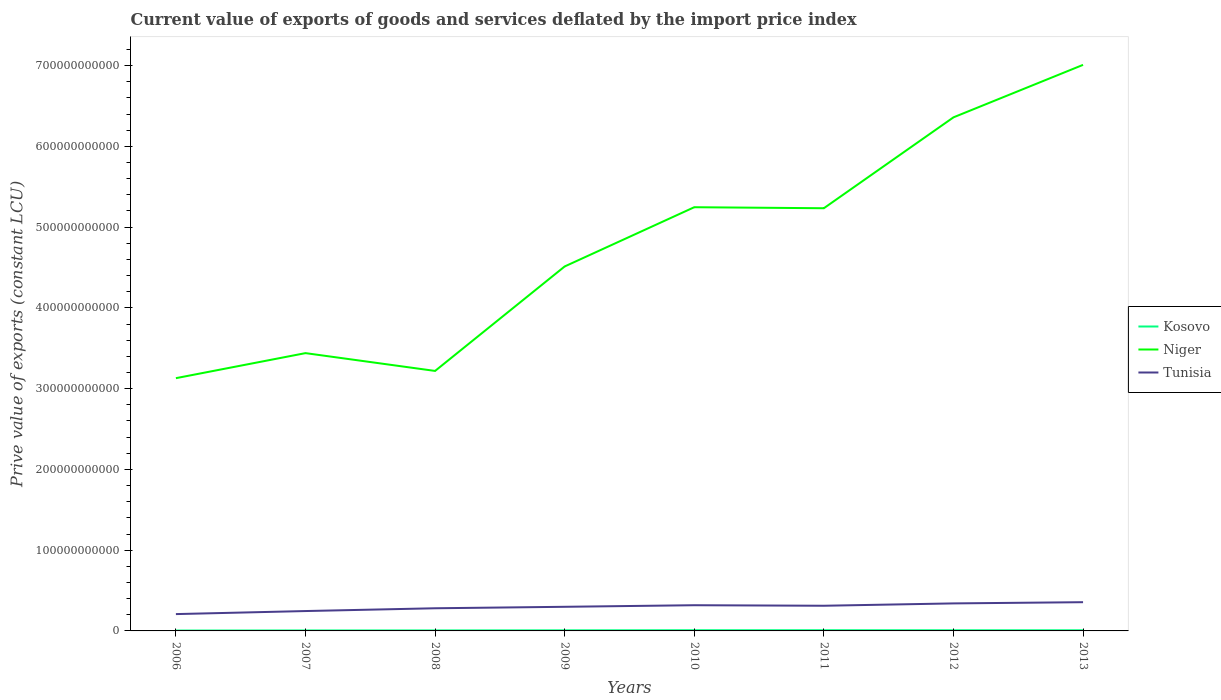Across all years, what is the maximum prive value of exports in Niger?
Provide a short and direct response. 3.13e+11. In which year was the prive value of exports in Kosovo maximum?
Offer a terse response. 2006. What is the total prive value of exports in Tunisia in the graph?
Give a very brief answer. -3.45e+09. What is the difference between the highest and the second highest prive value of exports in Niger?
Offer a terse response. 3.88e+11. What is the difference between the highest and the lowest prive value of exports in Niger?
Ensure brevity in your answer.  4. Is the prive value of exports in Tunisia strictly greater than the prive value of exports in Kosovo over the years?
Make the answer very short. No. What is the difference between two consecutive major ticks on the Y-axis?
Your response must be concise. 1.00e+11. Does the graph contain any zero values?
Offer a terse response. No. Does the graph contain grids?
Offer a very short reply. No. Where does the legend appear in the graph?
Your answer should be compact. Center right. How are the legend labels stacked?
Offer a very short reply. Vertical. What is the title of the graph?
Offer a very short reply. Current value of exports of goods and services deflated by the import price index. What is the label or title of the X-axis?
Make the answer very short. Years. What is the label or title of the Y-axis?
Provide a short and direct response. Prive value of exports (constant LCU). What is the Prive value of exports (constant LCU) of Kosovo in 2006?
Ensure brevity in your answer.  4.62e+08. What is the Prive value of exports (constant LCU) in Niger in 2006?
Make the answer very short. 3.13e+11. What is the Prive value of exports (constant LCU) in Tunisia in 2006?
Offer a terse response. 2.08e+1. What is the Prive value of exports (constant LCU) in Kosovo in 2007?
Offer a terse response. 5.88e+08. What is the Prive value of exports (constant LCU) in Niger in 2007?
Ensure brevity in your answer.  3.44e+11. What is the Prive value of exports (constant LCU) of Tunisia in 2007?
Give a very brief answer. 2.46e+1. What is the Prive value of exports (constant LCU) of Kosovo in 2008?
Make the answer very short. 6.11e+08. What is the Prive value of exports (constant LCU) of Niger in 2008?
Provide a succinct answer. 3.22e+11. What is the Prive value of exports (constant LCU) of Tunisia in 2008?
Provide a short and direct response. 2.81e+1. What is the Prive value of exports (constant LCU) of Kosovo in 2009?
Ensure brevity in your answer.  7.33e+08. What is the Prive value of exports (constant LCU) of Niger in 2009?
Your response must be concise. 4.51e+11. What is the Prive value of exports (constant LCU) of Tunisia in 2009?
Keep it short and to the point. 2.99e+1. What is the Prive value of exports (constant LCU) of Kosovo in 2010?
Offer a very short reply. 8.72e+08. What is the Prive value of exports (constant LCU) in Niger in 2010?
Give a very brief answer. 5.25e+11. What is the Prive value of exports (constant LCU) of Tunisia in 2010?
Your response must be concise. 3.18e+1. What is the Prive value of exports (constant LCU) in Kosovo in 2011?
Make the answer very short. 8.70e+08. What is the Prive value of exports (constant LCU) in Niger in 2011?
Make the answer very short. 5.23e+11. What is the Prive value of exports (constant LCU) in Tunisia in 2011?
Keep it short and to the point. 3.12e+1. What is the Prive value of exports (constant LCU) in Kosovo in 2012?
Your answer should be very brief. 8.13e+08. What is the Prive value of exports (constant LCU) of Niger in 2012?
Ensure brevity in your answer.  6.36e+11. What is the Prive value of exports (constant LCU) in Tunisia in 2012?
Your response must be concise. 3.41e+1. What is the Prive value of exports (constant LCU) in Kosovo in 2013?
Offer a terse response. 8.15e+08. What is the Prive value of exports (constant LCU) of Niger in 2013?
Make the answer very short. 7.01e+11. What is the Prive value of exports (constant LCU) of Tunisia in 2013?
Provide a short and direct response. 3.56e+1. Across all years, what is the maximum Prive value of exports (constant LCU) in Kosovo?
Your answer should be very brief. 8.72e+08. Across all years, what is the maximum Prive value of exports (constant LCU) in Niger?
Keep it short and to the point. 7.01e+11. Across all years, what is the maximum Prive value of exports (constant LCU) of Tunisia?
Your answer should be very brief. 3.56e+1. Across all years, what is the minimum Prive value of exports (constant LCU) in Kosovo?
Provide a short and direct response. 4.62e+08. Across all years, what is the minimum Prive value of exports (constant LCU) of Niger?
Offer a very short reply. 3.13e+11. Across all years, what is the minimum Prive value of exports (constant LCU) of Tunisia?
Offer a very short reply. 2.08e+1. What is the total Prive value of exports (constant LCU) of Kosovo in the graph?
Ensure brevity in your answer.  5.76e+09. What is the total Prive value of exports (constant LCU) in Niger in the graph?
Keep it short and to the point. 3.82e+12. What is the total Prive value of exports (constant LCU) of Tunisia in the graph?
Provide a short and direct response. 2.36e+11. What is the difference between the Prive value of exports (constant LCU) of Kosovo in 2006 and that in 2007?
Keep it short and to the point. -1.26e+08. What is the difference between the Prive value of exports (constant LCU) in Niger in 2006 and that in 2007?
Provide a succinct answer. -3.10e+1. What is the difference between the Prive value of exports (constant LCU) of Tunisia in 2006 and that in 2007?
Your answer should be very brief. -3.77e+09. What is the difference between the Prive value of exports (constant LCU) in Kosovo in 2006 and that in 2008?
Provide a short and direct response. -1.49e+08. What is the difference between the Prive value of exports (constant LCU) in Niger in 2006 and that in 2008?
Your answer should be compact. -8.97e+09. What is the difference between the Prive value of exports (constant LCU) in Tunisia in 2006 and that in 2008?
Your answer should be very brief. -7.22e+09. What is the difference between the Prive value of exports (constant LCU) in Kosovo in 2006 and that in 2009?
Make the answer very short. -2.71e+08. What is the difference between the Prive value of exports (constant LCU) of Niger in 2006 and that in 2009?
Make the answer very short. -1.38e+11. What is the difference between the Prive value of exports (constant LCU) in Tunisia in 2006 and that in 2009?
Keep it short and to the point. -9.04e+09. What is the difference between the Prive value of exports (constant LCU) of Kosovo in 2006 and that in 2010?
Provide a short and direct response. -4.10e+08. What is the difference between the Prive value of exports (constant LCU) of Niger in 2006 and that in 2010?
Give a very brief answer. -2.12e+11. What is the difference between the Prive value of exports (constant LCU) in Tunisia in 2006 and that in 2010?
Make the answer very short. -1.10e+1. What is the difference between the Prive value of exports (constant LCU) of Kosovo in 2006 and that in 2011?
Offer a terse response. -4.08e+08. What is the difference between the Prive value of exports (constant LCU) in Niger in 2006 and that in 2011?
Provide a succinct answer. -2.10e+11. What is the difference between the Prive value of exports (constant LCU) of Tunisia in 2006 and that in 2011?
Ensure brevity in your answer.  -1.03e+1. What is the difference between the Prive value of exports (constant LCU) of Kosovo in 2006 and that in 2012?
Ensure brevity in your answer.  -3.51e+08. What is the difference between the Prive value of exports (constant LCU) in Niger in 2006 and that in 2012?
Provide a succinct answer. -3.23e+11. What is the difference between the Prive value of exports (constant LCU) of Tunisia in 2006 and that in 2012?
Your answer should be compact. -1.32e+1. What is the difference between the Prive value of exports (constant LCU) of Kosovo in 2006 and that in 2013?
Make the answer very short. -3.53e+08. What is the difference between the Prive value of exports (constant LCU) of Niger in 2006 and that in 2013?
Provide a short and direct response. -3.88e+11. What is the difference between the Prive value of exports (constant LCU) in Tunisia in 2006 and that in 2013?
Make the answer very short. -1.48e+1. What is the difference between the Prive value of exports (constant LCU) of Kosovo in 2007 and that in 2008?
Make the answer very short. -2.31e+07. What is the difference between the Prive value of exports (constant LCU) in Niger in 2007 and that in 2008?
Offer a terse response. 2.20e+1. What is the difference between the Prive value of exports (constant LCU) in Tunisia in 2007 and that in 2008?
Keep it short and to the point. -3.45e+09. What is the difference between the Prive value of exports (constant LCU) of Kosovo in 2007 and that in 2009?
Your answer should be compact. -1.45e+08. What is the difference between the Prive value of exports (constant LCU) in Niger in 2007 and that in 2009?
Your answer should be very brief. -1.07e+11. What is the difference between the Prive value of exports (constant LCU) of Tunisia in 2007 and that in 2009?
Ensure brevity in your answer.  -5.27e+09. What is the difference between the Prive value of exports (constant LCU) in Kosovo in 2007 and that in 2010?
Give a very brief answer. -2.84e+08. What is the difference between the Prive value of exports (constant LCU) in Niger in 2007 and that in 2010?
Offer a terse response. -1.81e+11. What is the difference between the Prive value of exports (constant LCU) in Tunisia in 2007 and that in 2010?
Make the answer very short. -7.23e+09. What is the difference between the Prive value of exports (constant LCU) in Kosovo in 2007 and that in 2011?
Your answer should be very brief. -2.82e+08. What is the difference between the Prive value of exports (constant LCU) of Niger in 2007 and that in 2011?
Your answer should be compact. -1.79e+11. What is the difference between the Prive value of exports (constant LCU) of Tunisia in 2007 and that in 2011?
Ensure brevity in your answer.  -6.57e+09. What is the difference between the Prive value of exports (constant LCU) of Kosovo in 2007 and that in 2012?
Offer a terse response. -2.25e+08. What is the difference between the Prive value of exports (constant LCU) of Niger in 2007 and that in 2012?
Ensure brevity in your answer.  -2.92e+11. What is the difference between the Prive value of exports (constant LCU) of Tunisia in 2007 and that in 2012?
Give a very brief answer. -9.47e+09. What is the difference between the Prive value of exports (constant LCU) of Kosovo in 2007 and that in 2013?
Provide a short and direct response. -2.27e+08. What is the difference between the Prive value of exports (constant LCU) of Niger in 2007 and that in 2013?
Keep it short and to the point. -3.57e+11. What is the difference between the Prive value of exports (constant LCU) in Tunisia in 2007 and that in 2013?
Your answer should be compact. -1.10e+1. What is the difference between the Prive value of exports (constant LCU) of Kosovo in 2008 and that in 2009?
Make the answer very short. -1.22e+08. What is the difference between the Prive value of exports (constant LCU) in Niger in 2008 and that in 2009?
Offer a terse response. -1.29e+11. What is the difference between the Prive value of exports (constant LCU) in Tunisia in 2008 and that in 2009?
Keep it short and to the point. -1.82e+09. What is the difference between the Prive value of exports (constant LCU) of Kosovo in 2008 and that in 2010?
Ensure brevity in your answer.  -2.61e+08. What is the difference between the Prive value of exports (constant LCU) of Niger in 2008 and that in 2010?
Provide a succinct answer. -2.03e+11. What is the difference between the Prive value of exports (constant LCU) in Tunisia in 2008 and that in 2010?
Your answer should be compact. -3.78e+09. What is the difference between the Prive value of exports (constant LCU) in Kosovo in 2008 and that in 2011?
Make the answer very short. -2.59e+08. What is the difference between the Prive value of exports (constant LCU) in Niger in 2008 and that in 2011?
Offer a terse response. -2.01e+11. What is the difference between the Prive value of exports (constant LCU) in Tunisia in 2008 and that in 2011?
Your response must be concise. -3.12e+09. What is the difference between the Prive value of exports (constant LCU) of Kosovo in 2008 and that in 2012?
Your response must be concise. -2.02e+08. What is the difference between the Prive value of exports (constant LCU) of Niger in 2008 and that in 2012?
Provide a short and direct response. -3.14e+11. What is the difference between the Prive value of exports (constant LCU) of Tunisia in 2008 and that in 2012?
Your response must be concise. -6.02e+09. What is the difference between the Prive value of exports (constant LCU) in Kosovo in 2008 and that in 2013?
Provide a succinct answer. -2.04e+08. What is the difference between the Prive value of exports (constant LCU) of Niger in 2008 and that in 2013?
Make the answer very short. -3.79e+11. What is the difference between the Prive value of exports (constant LCU) in Tunisia in 2008 and that in 2013?
Offer a very short reply. -7.53e+09. What is the difference between the Prive value of exports (constant LCU) in Kosovo in 2009 and that in 2010?
Keep it short and to the point. -1.39e+08. What is the difference between the Prive value of exports (constant LCU) in Niger in 2009 and that in 2010?
Give a very brief answer. -7.34e+1. What is the difference between the Prive value of exports (constant LCU) in Tunisia in 2009 and that in 2010?
Provide a short and direct response. -1.96e+09. What is the difference between the Prive value of exports (constant LCU) of Kosovo in 2009 and that in 2011?
Make the answer very short. -1.38e+08. What is the difference between the Prive value of exports (constant LCU) of Niger in 2009 and that in 2011?
Offer a very short reply. -7.21e+1. What is the difference between the Prive value of exports (constant LCU) in Tunisia in 2009 and that in 2011?
Provide a short and direct response. -1.31e+09. What is the difference between the Prive value of exports (constant LCU) of Kosovo in 2009 and that in 2012?
Your answer should be very brief. -8.05e+07. What is the difference between the Prive value of exports (constant LCU) of Niger in 2009 and that in 2012?
Keep it short and to the point. -1.85e+11. What is the difference between the Prive value of exports (constant LCU) in Tunisia in 2009 and that in 2012?
Provide a short and direct response. -4.20e+09. What is the difference between the Prive value of exports (constant LCU) of Kosovo in 2009 and that in 2013?
Your answer should be compact. -8.19e+07. What is the difference between the Prive value of exports (constant LCU) of Niger in 2009 and that in 2013?
Offer a very short reply. -2.50e+11. What is the difference between the Prive value of exports (constant LCU) of Tunisia in 2009 and that in 2013?
Provide a short and direct response. -5.72e+09. What is the difference between the Prive value of exports (constant LCU) in Kosovo in 2010 and that in 2011?
Make the answer very short. 1.89e+06. What is the difference between the Prive value of exports (constant LCU) in Niger in 2010 and that in 2011?
Offer a very short reply. 1.26e+09. What is the difference between the Prive value of exports (constant LCU) of Tunisia in 2010 and that in 2011?
Your response must be concise. 6.51e+08. What is the difference between the Prive value of exports (constant LCU) in Kosovo in 2010 and that in 2012?
Provide a short and direct response. 5.89e+07. What is the difference between the Prive value of exports (constant LCU) of Niger in 2010 and that in 2012?
Your answer should be compact. -1.11e+11. What is the difference between the Prive value of exports (constant LCU) in Tunisia in 2010 and that in 2012?
Keep it short and to the point. -2.24e+09. What is the difference between the Prive value of exports (constant LCU) in Kosovo in 2010 and that in 2013?
Offer a very short reply. 5.75e+07. What is the difference between the Prive value of exports (constant LCU) of Niger in 2010 and that in 2013?
Keep it short and to the point. -1.76e+11. What is the difference between the Prive value of exports (constant LCU) in Tunisia in 2010 and that in 2013?
Ensure brevity in your answer.  -3.76e+09. What is the difference between the Prive value of exports (constant LCU) of Kosovo in 2011 and that in 2012?
Make the answer very short. 5.70e+07. What is the difference between the Prive value of exports (constant LCU) in Niger in 2011 and that in 2012?
Your answer should be compact. -1.13e+11. What is the difference between the Prive value of exports (constant LCU) of Tunisia in 2011 and that in 2012?
Your answer should be compact. -2.90e+09. What is the difference between the Prive value of exports (constant LCU) of Kosovo in 2011 and that in 2013?
Give a very brief answer. 5.57e+07. What is the difference between the Prive value of exports (constant LCU) of Niger in 2011 and that in 2013?
Give a very brief answer. -1.78e+11. What is the difference between the Prive value of exports (constant LCU) in Tunisia in 2011 and that in 2013?
Your answer should be very brief. -4.41e+09. What is the difference between the Prive value of exports (constant LCU) in Kosovo in 2012 and that in 2013?
Keep it short and to the point. -1.38e+06. What is the difference between the Prive value of exports (constant LCU) in Niger in 2012 and that in 2013?
Your answer should be compact. -6.50e+1. What is the difference between the Prive value of exports (constant LCU) in Tunisia in 2012 and that in 2013?
Keep it short and to the point. -1.51e+09. What is the difference between the Prive value of exports (constant LCU) of Kosovo in 2006 and the Prive value of exports (constant LCU) of Niger in 2007?
Your response must be concise. -3.44e+11. What is the difference between the Prive value of exports (constant LCU) of Kosovo in 2006 and the Prive value of exports (constant LCU) of Tunisia in 2007?
Offer a very short reply. -2.41e+1. What is the difference between the Prive value of exports (constant LCU) in Niger in 2006 and the Prive value of exports (constant LCU) in Tunisia in 2007?
Give a very brief answer. 2.88e+11. What is the difference between the Prive value of exports (constant LCU) in Kosovo in 2006 and the Prive value of exports (constant LCU) in Niger in 2008?
Provide a succinct answer. -3.21e+11. What is the difference between the Prive value of exports (constant LCU) in Kosovo in 2006 and the Prive value of exports (constant LCU) in Tunisia in 2008?
Provide a short and direct response. -2.76e+1. What is the difference between the Prive value of exports (constant LCU) in Niger in 2006 and the Prive value of exports (constant LCU) in Tunisia in 2008?
Provide a short and direct response. 2.85e+11. What is the difference between the Prive value of exports (constant LCU) in Kosovo in 2006 and the Prive value of exports (constant LCU) in Niger in 2009?
Offer a very short reply. -4.51e+11. What is the difference between the Prive value of exports (constant LCU) in Kosovo in 2006 and the Prive value of exports (constant LCU) in Tunisia in 2009?
Provide a short and direct response. -2.94e+1. What is the difference between the Prive value of exports (constant LCU) of Niger in 2006 and the Prive value of exports (constant LCU) of Tunisia in 2009?
Your response must be concise. 2.83e+11. What is the difference between the Prive value of exports (constant LCU) of Kosovo in 2006 and the Prive value of exports (constant LCU) of Niger in 2010?
Offer a very short reply. -5.24e+11. What is the difference between the Prive value of exports (constant LCU) in Kosovo in 2006 and the Prive value of exports (constant LCU) in Tunisia in 2010?
Keep it short and to the point. -3.14e+1. What is the difference between the Prive value of exports (constant LCU) of Niger in 2006 and the Prive value of exports (constant LCU) of Tunisia in 2010?
Keep it short and to the point. 2.81e+11. What is the difference between the Prive value of exports (constant LCU) in Kosovo in 2006 and the Prive value of exports (constant LCU) in Niger in 2011?
Make the answer very short. -5.23e+11. What is the difference between the Prive value of exports (constant LCU) of Kosovo in 2006 and the Prive value of exports (constant LCU) of Tunisia in 2011?
Give a very brief answer. -3.07e+1. What is the difference between the Prive value of exports (constant LCU) of Niger in 2006 and the Prive value of exports (constant LCU) of Tunisia in 2011?
Offer a very short reply. 2.82e+11. What is the difference between the Prive value of exports (constant LCU) of Kosovo in 2006 and the Prive value of exports (constant LCU) of Niger in 2012?
Keep it short and to the point. -6.35e+11. What is the difference between the Prive value of exports (constant LCU) in Kosovo in 2006 and the Prive value of exports (constant LCU) in Tunisia in 2012?
Your answer should be compact. -3.36e+1. What is the difference between the Prive value of exports (constant LCU) of Niger in 2006 and the Prive value of exports (constant LCU) of Tunisia in 2012?
Your answer should be compact. 2.79e+11. What is the difference between the Prive value of exports (constant LCU) of Kosovo in 2006 and the Prive value of exports (constant LCU) of Niger in 2013?
Your answer should be very brief. -7.00e+11. What is the difference between the Prive value of exports (constant LCU) in Kosovo in 2006 and the Prive value of exports (constant LCU) in Tunisia in 2013?
Keep it short and to the point. -3.51e+1. What is the difference between the Prive value of exports (constant LCU) of Niger in 2006 and the Prive value of exports (constant LCU) of Tunisia in 2013?
Your answer should be very brief. 2.77e+11. What is the difference between the Prive value of exports (constant LCU) of Kosovo in 2007 and the Prive value of exports (constant LCU) of Niger in 2008?
Provide a succinct answer. -3.21e+11. What is the difference between the Prive value of exports (constant LCU) in Kosovo in 2007 and the Prive value of exports (constant LCU) in Tunisia in 2008?
Provide a short and direct response. -2.75e+1. What is the difference between the Prive value of exports (constant LCU) of Niger in 2007 and the Prive value of exports (constant LCU) of Tunisia in 2008?
Ensure brevity in your answer.  3.16e+11. What is the difference between the Prive value of exports (constant LCU) of Kosovo in 2007 and the Prive value of exports (constant LCU) of Niger in 2009?
Your answer should be compact. -4.51e+11. What is the difference between the Prive value of exports (constant LCU) of Kosovo in 2007 and the Prive value of exports (constant LCU) of Tunisia in 2009?
Your response must be concise. -2.93e+1. What is the difference between the Prive value of exports (constant LCU) of Niger in 2007 and the Prive value of exports (constant LCU) of Tunisia in 2009?
Give a very brief answer. 3.14e+11. What is the difference between the Prive value of exports (constant LCU) of Kosovo in 2007 and the Prive value of exports (constant LCU) of Niger in 2010?
Your answer should be very brief. -5.24e+11. What is the difference between the Prive value of exports (constant LCU) of Kosovo in 2007 and the Prive value of exports (constant LCU) of Tunisia in 2010?
Keep it short and to the point. -3.12e+1. What is the difference between the Prive value of exports (constant LCU) in Niger in 2007 and the Prive value of exports (constant LCU) in Tunisia in 2010?
Ensure brevity in your answer.  3.12e+11. What is the difference between the Prive value of exports (constant LCU) of Kosovo in 2007 and the Prive value of exports (constant LCU) of Niger in 2011?
Your response must be concise. -5.23e+11. What is the difference between the Prive value of exports (constant LCU) of Kosovo in 2007 and the Prive value of exports (constant LCU) of Tunisia in 2011?
Provide a short and direct response. -3.06e+1. What is the difference between the Prive value of exports (constant LCU) in Niger in 2007 and the Prive value of exports (constant LCU) in Tunisia in 2011?
Your response must be concise. 3.13e+11. What is the difference between the Prive value of exports (constant LCU) in Kosovo in 2007 and the Prive value of exports (constant LCU) in Niger in 2012?
Make the answer very short. -6.35e+11. What is the difference between the Prive value of exports (constant LCU) in Kosovo in 2007 and the Prive value of exports (constant LCU) in Tunisia in 2012?
Your response must be concise. -3.35e+1. What is the difference between the Prive value of exports (constant LCU) in Niger in 2007 and the Prive value of exports (constant LCU) in Tunisia in 2012?
Provide a short and direct response. 3.10e+11. What is the difference between the Prive value of exports (constant LCU) of Kosovo in 2007 and the Prive value of exports (constant LCU) of Niger in 2013?
Ensure brevity in your answer.  -7.00e+11. What is the difference between the Prive value of exports (constant LCU) of Kosovo in 2007 and the Prive value of exports (constant LCU) of Tunisia in 2013?
Provide a succinct answer. -3.50e+1. What is the difference between the Prive value of exports (constant LCU) of Niger in 2007 and the Prive value of exports (constant LCU) of Tunisia in 2013?
Your answer should be very brief. 3.08e+11. What is the difference between the Prive value of exports (constant LCU) of Kosovo in 2008 and the Prive value of exports (constant LCU) of Niger in 2009?
Make the answer very short. -4.51e+11. What is the difference between the Prive value of exports (constant LCU) of Kosovo in 2008 and the Prive value of exports (constant LCU) of Tunisia in 2009?
Your answer should be compact. -2.93e+1. What is the difference between the Prive value of exports (constant LCU) in Niger in 2008 and the Prive value of exports (constant LCU) in Tunisia in 2009?
Offer a very short reply. 2.92e+11. What is the difference between the Prive value of exports (constant LCU) of Kosovo in 2008 and the Prive value of exports (constant LCU) of Niger in 2010?
Your response must be concise. -5.24e+11. What is the difference between the Prive value of exports (constant LCU) in Kosovo in 2008 and the Prive value of exports (constant LCU) in Tunisia in 2010?
Keep it short and to the point. -3.12e+1. What is the difference between the Prive value of exports (constant LCU) in Niger in 2008 and the Prive value of exports (constant LCU) in Tunisia in 2010?
Your answer should be very brief. 2.90e+11. What is the difference between the Prive value of exports (constant LCU) in Kosovo in 2008 and the Prive value of exports (constant LCU) in Niger in 2011?
Your answer should be compact. -5.23e+11. What is the difference between the Prive value of exports (constant LCU) of Kosovo in 2008 and the Prive value of exports (constant LCU) of Tunisia in 2011?
Provide a succinct answer. -3.06e+1. What is the difference between the Prive value of exports (constant LCU) in Niger in 2008 and the Prive value of exports (constant LCU) in Tunisia in 2011?
Provide a succinct answer. 2.91e+11. What is the difference between the Prive value of exports (constant LCU) in Kosovo in 2008 and the Prive value of exports (constant LCU) in Niger in 2012?
Make the answer very short. -6.35e+11. What is the difference between the Prive value of exports (constant LCU) in Kosovo in 2008 and the Prive value of exports (constant LCU) in Tunisia in 2012?
Ensure brevity in your answer.  -3.35e+1. What is the difference between the Prive value of exports (constant LCU) in Niger in 2008 and the Prive value of exports (constant LCU) in Tunisia in 2012?
Your answer should be very brief. 2.88e+11. What is the difference between the Prive value of exports (constant LCU) of Kosovo in 2008 and the Prive value of exports (constant LCU) of Niger in 2013?
Your answer should be compact. -7.00e+11. What is the difference between the Prive value of exports (constant LCU) in Kosovo in 2008 and the Prive value of exports (constant LCU) in Tunisia in 2013?
Keep it short and to the point. -3.50e+1. What is the difference between the Prive value of exports (constant LCU) in Niger in 2008 and the Prive value of exports (constant LCU) in Tunisia in 2013?
Offer a terse response. 2.86e+11. What is the difference between the Prive value of exports (constant LCU) of Kosovo in 2009 and the Prive value of exports (constant LCU) of Niger in 2010?
Offer a terse response. -5.24e+11. What is the difference between the Prive value of exports (constant LCU) of Kosovo in 2009 and the Prive value of exports (constant LCU) of Tunisia in 2010?
Ensure brevity in your answer.  -3.11e+1. What is the difference between the Prive value of exports (constant LCU) of Niger in 2009 and the Prive value of exports (constant LCU) of Tunisia in 2010?
Your response must be concise. 4.19e+11. What is the difference between the Prive value of exports (constant LCU) in Kosovo in 2009 and the Prive value of exports (constant LCU) in Niger in 2011?
Offer a terse response. -5.23e+11. What is the difference between the Prive value of exports (constant LCU) of Kosovo in 2009 and the Prive value of exports (constant LCU) of Tunisia in 2011?
Provide a short and direct response. -3.04e+1. What is the difference between the Prive value of exports (constant LCU) in Niger in 2009 and the Prive value of exports (constant LCU) in Tunisia in 2011?
Ensure brevity in your answer.  4.20e+11. What is the difference between the Prive value of exports (constant LCU) in Kosovo in 2009 and the Prive value of exports (constant LCU) in Niger in 2012?
Provide a short and direct response. -6.35e+11. What is the difference between the Prive value of exports (constant LCU) of Kosovo in 2009 and the Prive value of exports (constant LCU) of Tunisia in 2012?
Give a very brief answer. -3.33e+1. What is the difference between the Prive value of exports (constant LCU) of Niger in 2009 and the Prive value of exports (constant LCU) of Tunisia in 2012?
Provide a succinct answer. 4.17e+11. What is the difference between the Prive value of exports (constant LCU) of Kosovo in 2009 and the Prive value of exports (constant LCU) of Niger in 2013?
Offer a terse response. -7.00e+11. What is the difference between the Prive value of exports (constant LCU) of Kosovo in 2009 and the Prive value of exports (constant LCU) of Tunisia in 2013?
Keep it short and to the point. -3.49e+1. What is the difference between the Prive value of exports (constant LCU) of Niger in 2009 and the Prive value of exports (constant LCU) of Tunisia in 2013?
Your answer should be compact. 4.16e+11. What is the difference between the Prive value of exports (constant LCU) of Kosovo in 2010 and the Prive value of exports (constant LCU) of Niger in 2011?
Your response must be concise. -5.23e+11. What is the difference between the Prive value of exports (constant LCU) in Kosovo in 2010 and the Prive value of exports (constant LCU) in Tunisia in 2011?
Keep it short and to the point. -3.03e+1. What is the difference between the Prive value of exports (constant LCU) of Niger in 2010 and the Prive value of exports (constant LCU) of Tunisia in 2011?
Provide a short and direct response. 4.93e+11. What is the difference between the Prive value of exports (constant LCU) in Kosovo in 2010 and the Prive value of exports (constant LCU) in Niger in 2012?
Your response must be concise. -6.35e+11. What is the difference between the Prive value of exports (constant LCU) of Kosovo in 2010 and the Prive value of exports (constant LCU) of Tunisia in 2012?
Provide a succinct answer. -3.32e+1. What is the difference between the Prive value of exports (constant LCU) in Niger in 2010 and the Prive value of exports (constant LCU) in Tunisia in 2012?
Offer a terse response. 4.91e+11. What is the difference between the Prive value of exports (constant LCU) in Kosovo in 2010 and the Prive value of exports (constant LCU) in Niger in 2013?
Give a very brief answer. -7.00e+11. What is the difference between the Prive value of exports (constant LCU) of Kosovo in 2010 and the Prive value of exports (constant LCU) of Tunisia in 2013?
Provide a succinct answer. -3.47e+1. What is the difference between the Prive value of exports (constant LCU) of Niger in 2010 and the Prive value of exports (constant LCU) of Tunisia in 2013?
Offer a terse response. 4.89e+11. What is the difference between the Prive value of exports (constant LCU) in Kosovo in 2011 and the Prive value of exports (constant LCU) in Niger in 2012?
Offer a very short reply. -6.35e+11. What is the difference between the Prive value of exports (constant LCU) in Kosovo in 2011 and the Prive value of exports (constant LCU) in Tunisia in 2012?
Give a very brief answer. -3.32e+1. What is the difference between the Prive value of exports (constant LCU) of Niger in 2011 and the Prive value of exports (constant LCU) of Tunisia in 2012?
Make the answer very short. 4.89e+11. What is the difference between the Prive value of exports (constant LCU) of Kosovo in 2011 and the Prive value of exports (constant LCU) of Niger in 2013?
Offer a terse response. -7.00e+11. What is the difference between the Prive value of exports (constant LCU) of Kosovo in 2011 and the Prive value of exports (constant LCU) of Tunisia in 2013?
Ensure brevity in your answer.  -3.47e+1. What is the difference between the Prive value of exports (constant LCU) in Niger in 2011 and the Prive value of exports (constant LCU) in Tunisia in 2013?
Your answer should be compact. 4.88e+11. What is the difference between the Prive value of exports (constant LCU) of Kosovo in 2012 and the Prive value of exports (constant LCU) of Niger in 2013?
Offer a very short reply. -7.00e+11. What is the difference between the Prive value of exports (constant LCU) of Kosovo in 2012 and the Prive value of exports (constant LCU) of Tunisia in 2013?
Your response must be concise. -3.48e+1. What is the difference between the Prive value of exports (constant LCU) in Niger in 2012 and the Prive value of exports (constant LCU) in Tunisia in 2013?
Keep it short and to the point. 6.00e+11. What is the average Prive value of exports (constant LCU) in Kosovo per year?
Your answer should be very brief. 7.20e+08. What is the average Prive value of exports (constant LCU) in Niger per year?
Your answer should be compact. 4.77e+11. What is the average Prive value of exports (constant LCU) of Tunisia per year?
Offer a very short reply. 2.95e+1. In the year 2006, what is the difference between the Prive value of exports (constant LCU) in Kosovo and Prive value of exports (constant LCU) in Niger?
Your answer should be very brief. -3.12e+11. In the year 2006, what is the difference between the Prive value of exports (constant LCU) of Kosovo and Prive value of exports (constant LCU) of Tunisia?
Offer a terse response. -2.04e+1. In the year 2006, what is the difference between the Prive value of exports (constant LCU) of Niger and Prive value of exports (constant LCU) of Tunisia?
Make the answer very short. 2.92e+11. In the year 2007, what is the difference between the Prive value of exports (constant LCU) in Kosovo and Prive value of exports (constant LCU) in Niger?
Keep it short and to the point. -3.43e+11. In the year 2007, what is the difference between the Prive value of exports (constant LCU) in Kosovo and Prive value of exports (constant LCU) in Tunisia?
Give a very brief answer. -2.40e+1. In the year 2007, what is the difference between the Prive value of exports (constant LCU) of Niger and Prive value of exports (constant LCU) of Tunisia?
Keep it short and to the point. 3.19e+11. In the year 2008, what is the difference between the Prive value of exports (constant LCU) in Kosovo and Prive value of exports (constant LCU) in Niger?
Provide a short and direct response. -3.21e+11. In the year 2008, what is the difference between the Prive value of exports (constant LCU) of Kosovo and Prive value of exports (constant LCU) of Tunisia?
Ensure brevity in your answer.  -2.74e+1. In the year 2008, what is the difference between the Prive value of exports (constant LCU) of Niger and Prive value of exports (constant LCU) of Tunisia?
Your answer should be compact. 2.94e+11. In the year 2009, what is the difference between the Prive value of exports (constant LCU) of Kosovo and Prive value of exports (constant LCU) of Niger?
Make the answer very short. -4.51e+11. In the year 2009, what is the difference between the Prive value of exports (constant LCU) of Kosovo and Prive value of exports (constant LCU) of Tunisia?
Your response must be concise. -2.91e+1. In the year 2009, what is the difference between the Prive value of exports (constant LCU) in Niger and Prive value of exports (constant LCU) in Tunisia?
Your response must be concise. 4.21e+11. In the year 2010, what is the difference between the Prive value of exports (constant LCU) in Kosovo and Prive value of exports (constant LCU) in Niger?
Give a very brief answer. -5.24e+11. In the year 2010, what is the difference between the Prive value of exports (constant LCU) of Kosovo and Prive value of exports (constant LCU) of Tunisia?
Provide a short and direct response. -3.10e+1. In the year 2010, what is the difference between the Prive value of exports (constant LCU) in Niger and Prive value of exports (constant LCU) in Tunisia?
Provide a short and direct response. 4.93e+11. In the year 2011, what is the difference between the Prive value of exports (constant LCU) of Kosovo and Prive value of exports (constant LCU) of Niger?
Your answer should be very brief. -5.23e+11. In the year 2011, what is the difference between the Prive value of exports (constant LCU) of Kosovo and Prive value of exports (constant LCU) of Tunisia?
Offer a very short reply. -3.03e+1. In the year 2011, what is the difference between the Prive value of exports (constant LCU) in Niger and Prive value of exports (constant LCU) in Tunisia?
Keep it short and to the point. 4.92e+11. In the year 2012, what is the difference between the Prive value of exports (constant LCU) of Kosovo and Prive value of exports (constant LCU) of Niger?
Provide a short and direct response. -6.35e+11. In the year 2012, what is the difference between the Prive value of exports (constant LCU) in Kosovo and Prive value of exports (constant LCU) in Tunisia?
Provide a short and direct response. -3.33e+1. In the year 2012, what is the difference between the Prive value of exports (constant LCU) in Niger and Prive value of exports (constant LCU) in Tunisia?
Make the answer very short. 6.02e+11. In the year 2013, what is the difference between the Prive value of exports (constant LCU) in Kosovo and Prive value of exports (constant LCU) in Niger?
Your answer should be very brief. -7.00e+11. In the year 2013, what is the difference between the Prive value of exports (constant LCU) of Kosovo and Prive value of exports (constant LCU) of Tunisia?
Your answer should be compact. -3.48e+1. In the year 2013, what is the difference between the Prive value of exports (constant LCU) in Niger and Prive value of exports (constant LCU) in Tunisia?
Keep it short and to the point. 6.65e+11. What is the ratio of the Prive value of exports (constant LCU) of Kosovo in 2006 to that in 2007?
Make the answer very short. 0.79. What is the ratio of the Prive value of exports (constant LCU) of Niger in 2006 to that in 2007?
Provide a succinct answer. 0.91. What is the ratio of the Prive value of exports (constant LCU) of Tunisia in 2006 to that in 2007?
Offer a terse response. 0.85. What is the ratio of the Prive value of exports (constant LCU) of Kosovo in 2006 to that in 2008?
Provide a short and direct response. 0.76. What is the ratio of the Prive value of exports (constant LCU) in Niger in 2006 to that in 2008?
Give a very brief answer. 0.97. What is the ratio of the Prive value of exports (constant LCU) of Tunisia in 2006 to that in 2008?
Make the answer very short. 0.74. What is the ratio of the Prive value of exports (constant LCU) in Kosovo in 2006 to that in 2009?
Your answer should be compact. 0.63. What is the ratio of the Prive value of exports (constant LCU) of Niger in 2006 to that in 2009?
Give a very brief answer. 0.69. What is the ratio of the Prive value of exports (constant LCU) in Tunisia in 2006 to that in 2009?
Give a very brief answer. 0.7. What is the ratio of the Prive value of exports (constant LCU) in Kosovo in 2006 to that in 2010?
Your response must be concise. 0.53. What is the ratio of the Prive value of exports (constant LCU) in Niger in 2006 to that in 2010?
Offer a very short reply. 0.6. What is the ratio of the Prive value of exports (constant LCU) of Tunisia in 2006 to that in 2010?
Your answer should be very brief. 0.65. What is the ratio of the Prive value of exports (constant LCU) of Kosovo in 2006 to that in 2011?
Your answer should be very brief. 0.53. What is the ratio of the Prive value of exports (constant LCU) of Niger in 2006 to that in 2011?
Your response must be concise. 0.6. What is the ratio of the Prive value of exports (constant LCU) in Tunisia in 2006 to that in 2011?
Your answer should be compact. 0.67. What is the ratio of the Prive value of exports (constant LCU) in Kosovo in 2006 to that in 2012?
Make the answer very short. 0.57. What is the ratio of the Prive value of exports (constant LCU) of Niger in 2006 to that in 2012?
Keep it short and to the point. 0.49. What is the ratio of the Prive value of exports (constant LCU) in Tunisia in 2006 to that in 2012?
Provide a succinct answer. 0.61. What is the ratio of the Prive value of exports (constant LCU) in Kosovo in 2006 to that in 2013?
Provide a succinct answer. 0.57. What is the ratio of the Prive value of exports (constant LCU) of Niger in 2006 to that in 2013?
Make the answer very short. 0.45. What is the ratio of the Prive value of exports (constant LCU) in Tunisia in 2006 to that in 2013?
Offer a terse response. 0.59. What is the ratio of the Prive value of exports (constant LCU) of Kosovo in 2007 to that in 2008?
Offer a terse response. 0.96. What is the ratio of the Prive value of exports (constant LCU) of Niger in 2007 to that in 2008?
Your answer should be compact. 1.07. What is the ratio of the Prive value of exports (constant LCU) of Tunisia in 2007 to that in 2008?
Offer a very short reply. 0.88. What is the ratio of the Prive value of exports (constant LCU) in Kosovo in 2007 to that in 2009?
Make the answer very short. 0.8. What is the ratio of the Prive value of exports (constant LCU) in Niger in 2007 to that in 2009?
Offer a terse response. 0.76. What is the ratio of the Prive value of exports (constant LCU) in Tunisia in 2007 to that in 2009?
Your answer should be compact. 0.82. What is the ratio of the Prive value of exports (constant LCU) of Kosovo in 2007 to that in 2010?
Provide a short and direct response. 0.67. What is the ratio of the Prive value of exports (constant LCU) in Niger in 2007 to that in 2010?
Give a very brief answer. 0.66. What is the ratio of the Prive value of exports (constant LCU) of Tunisia in 2007 to that in 2010?
Provide a succinct answer. 0.77. What is the ratio of the Prive value of exports (constant LCU) of Kosovo in 2007 to that in 2011?
Keep it short and to the point. 0.68. What is the ratio of the Prive value of exports (constant LCU) of Niger in 2007 to that in 2011?
Provide a succinct answer. 0.66. What is the ratio of the Prive value of exports (constant LCU) in Tunisia in 2007 to that in 2011?
Your answer should be very brief. 0.79. What is the ratio of the Prive value of exports (constant LCU) of Kosovo in 2007 to that in 2012?
Make the answer very short. 0.72. What is the ratio of the Prive value of exports (constant LCU) in Niger in 2007 to that in 2012?
Your answer should be very brief. 0.54. What is the ratio of the Prive value of exports (constant LCU) in Tunisia in 2007 to that in 2012?
Your answer should be compact. 0.72. What is the ratio of the Prive value of exports (constant LCU) in Kosovo in 2007 to that in 2013?
Keep it short and to the point. 0.72. What is the ratio of the Prive value of exports (constant LCU) of Niger in 2007 to that in 2013?
Offer a very short reply. 0.49. What is the ratio of the Prive value of exports (constant LCU) of Tunisia in 2007 to that in 2013?
Ensure brevity in your answer.  0.69. What is the ratio of the Prive value of exports (constant LCU) of Kosovo in 2008 to that in 2009?
Provide a succinct answer. 0.83. What is the ratio of the Prive value of exports (constant LCU) in Niger in 2008 to that in 2009?
Keep it short and to the point. 0.71. What is the ratio of the Prive value of exports (constant LCU) in Tunisia in 2008 to that in 2009?
Your answer should be very brief. 0.94. What is the ratio of the Prive value of exports (constant LCU) in Kosovo in 2008 to that in 2010?
Provide a succinct answer. 0.7. What is the ratio of the Prive value of exports (constant LCU) of Niger in 2008 to that in 2010?
Give a very brief answer. 0.61. What is the ratio of the Prive value of exports (constant LCU) in Tunisia in 2008 to that in 2010?
Your response must be concise. 0.88. What is the ratio of the Prive value of exports (constant LCU) in Kosovo in 2008 to that in 2011?
Provide a succinct answer. 0.7. What is the ratio of the Prive value of exports (constant LCU) of Niger in 2008 to that in 2011?
Provide a succinct answer. 0.62. What is the ratio of the Prive value of exports (constant LCU) in Tunisia in 2008 to that in 2011?
Your answer should be compact. 0.9. What is the ratio of the Prive value of exports (constant LCU) of Kosovo in 2008 to that in 2012?
Provide a short and direct response. 0.75. What is the ratio of the Prive value of exports (constant LCU) in Niger in 2008 to that in 2012?
Give a very brief answer. 0.51. What is the ratio of the Prive value of exports (constant LCU) in Tunisia in 2008 to that in 2012?
Offer a terse response. 0.82. What is the ratio of the Prive value of exports (constant LCU) of Kosovo in 2008 to that in 2013?
Your answer should be very brief. 0.75. What is the ratio of the Prive value of exports (constant LCU) in Niger in 2008 to that in 2013?
Give a very brief answer. 0.46. What is the ratio of the Prive value of exports (constant LCU) in Tunisia in 2008 to that in 2013?
Give a very brief answer. 0.79. What is the ratio of the Prive value of exports (constant LCU) in Kosovo in 2009 to that in 2010?
Provide a short and direct response. 0.84. What is the ratio of the Prive value of exports (constant LCU) of Niger in 2009 to that in 2010?
Your answer should be compact. 0.86. What is the ratio of the Prive value of exports (constant LCU) in Tunisia in 2009 to that in 2010?
Offer a terse response. 0.94. What is the ratio of the Prive value of exports (constant LCU) of Kosovo in 2009 to that in 2011?
Ensure brevity in your answer.  0.84. What is the ratio of the Prive value of exports (constant LCU) of Niger in 2009 to that in 2011?
Offer a very short reply. 0.86. What is the ratio of the Prive value of exports (constant LCU) of Tunisia in 2009 to that in 2011?
Ensure brevity in your answer.  0.96. What is the ratio of the Prive value of exports (constant LCU) in Kosovo in 2009 to that in 2012?
Your answer should be very brief. 0.9. What is the ratio of the Prive value of exports (constant LCU) of Niger in 2009 to that in 2012?
Your response must be concise. 0.71. What is the ratio of the Prive value of exports (constant LCU) of Tunisia in 2009 to that in 2012?
Give a very brief answer. 0.88. What is the ratio of the Prive value of exports (constant LCU) of Kosovo in 2009 to that in 2013?
Provide a short and direct response. 0.9. What is the ratio of the Prive value of exports (constant LCU) of Niger in 2009 to that in 2013?
Give a very brief answer. 0.64. What is the ratio of the Prive value of exports (constant LCU) in Tunisia in 2009 to that in 2013?
Provide a short and direct response. 0.84. What is the ratio of the Prive value of exports (constant LCU) of Niger in 2010 to that in 2011?
Keep it short and to the point. 1. What is the ratio of the Prive value of exports (constant LCU) in Tunisia in 2010 to that in 2011?
Offer a very short reply. 1.02. What is the ratio of the Prive value of exports (constant LCU) of Kosovo in 2010 to that in 2012?
Provide a short and direct response. 1.07. What is the ratio of the Prive value of exports (constant LCU) of Niger in 2010 to that in 2012?
Keep it short and to the point. 0.82. What is the ratio of the Prive value of exports (constant LCU) in Tunisia in 2010 to that in 2012?
Offer a terse response. 0.93. What is the ratio of the Prive value of exports (constant LCU) of Kosovo in 2010 to that in 2013?
Your answer should be very brief. 1.07. What is the ratio of the Prive value of exports (constant LCU) in Niger in 2010 to that in 2013?
Make the answer very short. 0.75. What is the ratio of the Prive value of exports (constant LCU) in Tunisia in 2010 to that in 2013?
Provide a succinct answer. 0.89. What is the ratio of the Prive value of exports (constant LCU) in Kosovo in 2011 to that in 2012?
Offer a terse response. 1.07. What is the ratio of the Prive value of exports (constant LCU) in Niger in 2011 to that in 2012?
Offer a very short reply. 0.82. What is the ratio of the Prive value of exports (constant LCU) in Tunisia in 2011 to that in 2012?
Keep it short and to the point. 0.92. What is the ratio of the Prive value of exports (constant LCU) in Kosovo in 2011 to that in 2013?
Your answer should be very brief. 1.07. What is the ratio of the Prive value of exports (constant LCU) in Niger in 2011 to that in 2013?
Your answer should be compact. 0.75. What is the ratio of the Prive value of exports (constant LCU) in Tunisia in 2011 to that in 2013?
Ensure brevity in your answer.  0.88. What is the ratio of the Prive value of exports (constant LCU) of Niger in 2012 to that in 2013?
Keep it short and to the point. 0.91. What is the ratio of the Prive value of exports (constant LCU) of Tunisia in 2012 to that in 2013?
Offer a very short reply. 0.96. What is the difference between the highest and the second highest Prive value of exports (constant LCU) in Kosovo?
Make the answer very short. 1.89e+06. What is the difference between the highest and the second highest Prive value of exports (constant LCU) in Niger?
Make the answer very short. 6.50e+1. What is the difference between the highest and the second highest Prive value of exports (constant LCU) of Tunisia?
Make the answer very short. 1.51e+09. What is the difference between the highest and the lowest Prive value of exports (constant LCU) in Kosovo?
Provide a short and direct response. 4.10e+08. What is the difference between the highest and the lowest Prive value of exports (constant LCU) of Niger?
Ensure brevity in your answer.  3.88e+11. What is the difference between the highest and the lowest Prive value of exports (constant LCU) in Tunisia?
Give a very brief answer. 1.48e+1. 